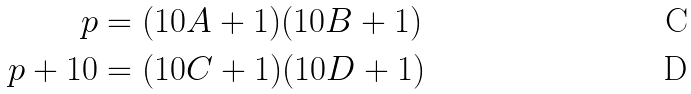<formula> <loc_0><loc_0><loc_500><loc_500>p & = ( 1 0 A + 1 ) ( 1 0 B + 1 ) \\ p + 1 0 & = ( 1 0 C + 1 ) ( 1 0 D + 1 )</formula> 